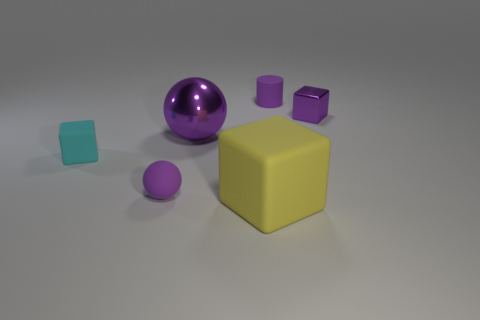Add 4 large gray matte spheres. How many objects exist? 10 Subtract all cylinders. How many objects are left? 5 Subtract all small purple rubber blocks. Subtract all small cubes. How many objects are left? 4 Add 6 large yellow things. How many large yellow things are left? 7 Add 4 purple cylinders. How many purple cylinders exist? 5 Subtract 0 green balls. How many objects are left? 6 